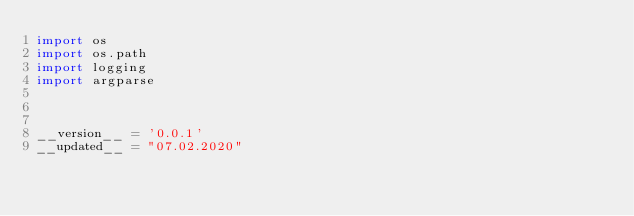<code> <loc_0><loc_0><loc_500><loc_500><_Python_>import os
import os.path
import logging
import argparse



__version__ = '0.0.1'
__updated__ = "07.02.2020"</code> 